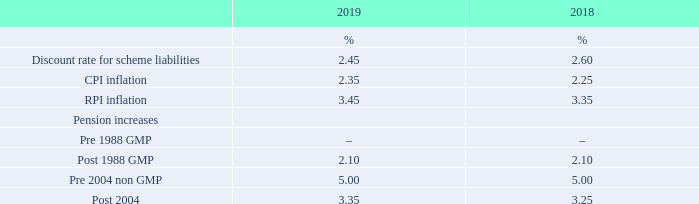Assumptions used
The last triennial actuarial valuation of the Scheme was performed by an independent professional actuary at 30 April 2018 using the projected unit method of valuation. For the purposes of IAS 19 (revised) the actuarial valuation as at 30 April 2018 has been updated on an approximate basis to 31 March 2019. There have been no changes in the valuation methodology adopted for this year’s disclosures compared to the prior year’s disclosures.
The principal financial assumptions used to calculate the liabilities under IAS 19 (revised) are as follows:
The financial assumptions reflect the nature and term of the Scheme’s liabilities.
What is the assumed Discount rate for scheme liabilities in 2019?
Answer scale should be: percent. 2.45. What do the financial assumptions reflect? The nature and term of the scheme’s liabilities. What are the types of inflation listed in the table? Cpi inflation, rpi inflation. In which year was CPI inflation percentage larger? 2.35%>2.25%
Answer: 2019. What was the change in CPI inflation percentage in 2019 from 2018?
Answer scale should be: percent. 2.35%-2.25%
Answer: 0.1. What was the average CPI inflation rate across 2018 and 2019?
Answer scale should be: percent. (2.35%+2.25%)/2
Answer: 2.3. 